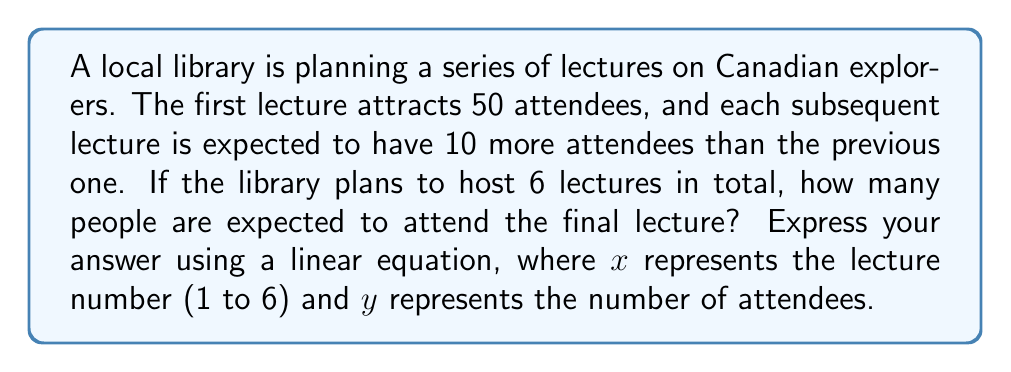Show me your answer to this math problem. To solve this problem, we'll use a linear equation in the form $y = mx + b$, where:
- $y$ is the number of attendees
- $x$ is the lecture number
- $m$ is the slope (increase in attendees per lecture)
- $b$ is the y-intercept (initial number of attendees)

Step 1: Identify the components of the linear equation
- Initial attendees (y-intercept): $b = 50$
- Increase per lecture (slope): $m = 10$

Step 2: Form the linear equation
$$y = 10x + 50$$

Step 3: Calculate the attendance for the final lecture
For the 6th lecture, $x = 6$
$$y = 10(6) + 50$$
$$y = 60 + 50$$
$$y = 110$$

Therefore, the final lecture is expected to have 110 attendees.
Answer: $y = 10x + 50$; 110 attendees 